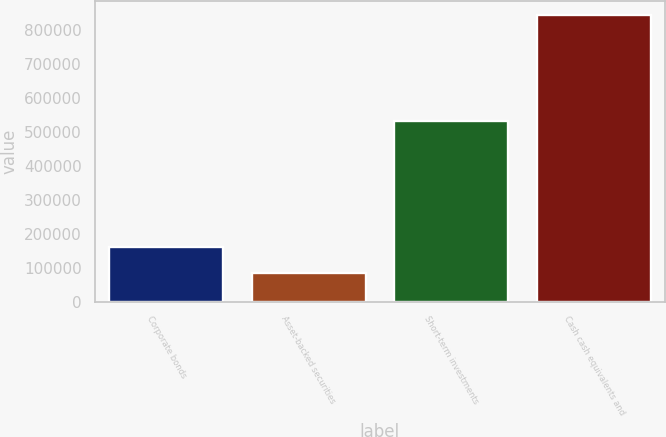Convert chart. <chart><loc_0><loc_0><loc_500><loc_500><bar_chart><fcel>Corporate bonds<fcel>Asset-backed securities<fcel>Short-term investments<fcel>Cash cash equivalents and<nl><fcel>160907<fcel>83517<fcel>530467<fcel>844084<nl></chart> 